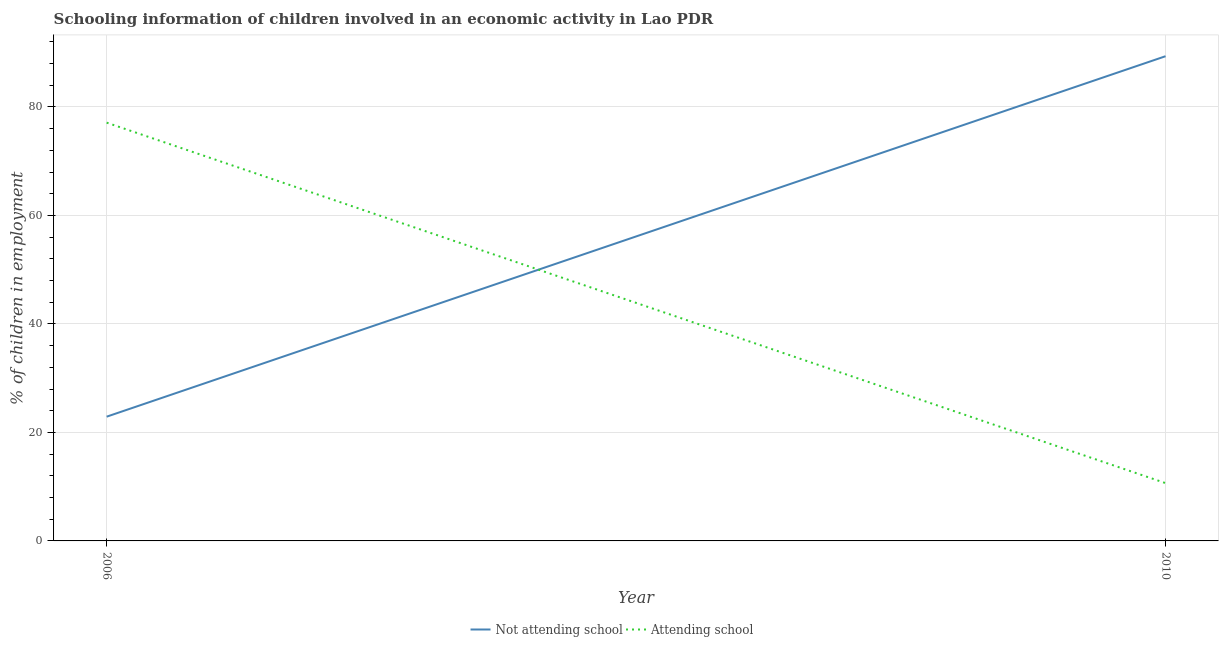What is the percentage of employed children who are not attending school in 2006?
Provide a short and direct response. 22.9. Across all years, what is the maximum percentage of employed children who are attending school?
Your response must be concise. 77.1. Across all years, what is the minimum percentage of employed children who are attending school?
Keep it short and to the point. 10.65. In which year was the percentage of employed children who are not attending school minimum?
Provide a short and direct response. 2006. What is the total percentage of employed children who are attending school in the graph?
Give a very brief answer. 87.75. What is the difference between the percentage of employed children who are attending school in 2006 and that in 2010?
Your answer should be compact. 66.45. What is the difference between the percentage of employed children who are not attending school in 2006 and the percentage of employed children who are attending school in 2010?
Your answer should be compact. 12.25. What is the average percentage of employed children who are not attending school per year?
Offer a very short reply. 56.12. In the year 2010, what is the difference between the percentage of employed children who are attending school and percentage of employed children who are not attending school?
Your answer should be compact. -78.69. What is the ratio of the percentage of employed children who are attending school in 2006 to that in 2010?
Provide a succinct answer. 7.24. In how many years, is the percentage of employed children who are not attending school greater than the average percentage of employed children who are not attending school taken over all years?
Offer a very short reply. 1. Does the percentage of employed children who are not attending school monotonically increase over the years?
Offer a very short reply. Yes. Are the values on the major ticks of Y-axis written in scientific E-notation?
Your response must be concise. No. Does the graph contain any zero values?
Make the answer very short. No. How are the legend labels stacked?
Give a very brief answer. Horizontal. What is the title of the graph?
Make the answer very short. Schooling information of children involved in an economic activity in Lao PDR. What is the label or title of the X-axis?
Your answer should be compact. Year. What is the label or title of the Y-axis?
Offer a very short reply. % of children in employment. What is the % of children in employment of Not attending school in 2006?
Keep it short and to the point. 22.9. What is the % of children in employment of Attending school in 2006?
Your answer should be compact. 77.1. What is the % of children in employment of Not attending school in 2010?
Provide a succinct answer. 89.35. What is the % of children in employment of Attending school in 2010?
Ensure brevity in your answer.  10.65. Across all years, what is the maximum % of children in employment in Not attending school?
Your response must be concise. 89.35. Across all years, what is the maximum % of children in employment in Attending school?
Your answer should be compact. 77.1. Across all years, what is the minimum % of children in employment in Not attending school?
Offer a very short reply. 22.9. Across all years, what is the minimum % of children in employment of Attending school?
Your answer should be compact. 10.65. What is the total % of children in employment in Not attending school in the graph?
Provide a succinct answer. 112.25. What is the total % of children in employment of Attending school in the graph?
Your answer should be compact. 87.75. What is the difference between the % of children in employment in Not attending school in 2006 and that in 2010?
Offer a terse response. -66.45. What is the difference between the % of children in employment of Attending school in 2006 and that in 2010?
Provide a succinct answer. 66.45. What is the difference between the % of children in employment of Not attending school in 2006 and the % of children in employment of Attending school in 2010?
Provide a succinct answer. 12.25. What is the average % of children in employment of Not attending school per year?
Your answer should be compact. 56.12. What is the average % of children in employment in Attending school per year?
Give a very brief answer. 43.88. In the year 2006, what is the difference between the % of children in employment in Not attending school and % of children in employment in Attending school?
Give a very brief answer. -54.2. In the year 2010, what is the difference between the % of children in employment of Not attending school and % of children in employment of Attending school?
Give a very brief answer. 78.69. What is the ratio of the % of children in employment of Not attending school in 2006 to that in 2010?
Ensure brevity in your answer.  0.26. What is the ratio of the % of children in employment in Attending school in 2006 to that in 2010?
Keep it short and to the point. 7.24. What is the difference between the highest and the second highest % of children in employment of Not attending school?
Offer a terse response. 66.45. What is the difference between the highest and the second highest % of children in employment in Attending school?
Ensure brevity in your answer.  66.45. What is the difference between the highest and the lowest % of children in employment in Not attending school?
Give a very brief answer. 66.45. What is the difference between the highest and the lowest % of children in employment of Attending school?
Offer a terse response. 66.45. 